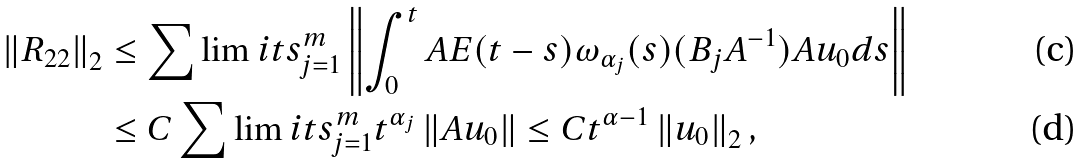<formula> <loc_0><loc_0><loc_500><loc_500>\left \| R _ { 2 2 } \right \| _ { 2 } & \leq \sum \lim i t s _ { j = 1 } ^ { m } \left \| \int _ { 0 } ^ { t } A E ( t - s ) \omega _ { \alpha _ { j } } ( s ) ( B _ { j } A ^ { - 1 } ) A u _ { 0 } d s \right \| \\ & \leq C \sum \lim i t s _ { j = 1 } ^ { m } t ^ { \alpha _ { j } } \left \| A u _ { 0 } \right \| \leq C t ^ { \alpha - 1 } \left \| u _ { 0 } \right \| _ { 2 } ,</formula> 